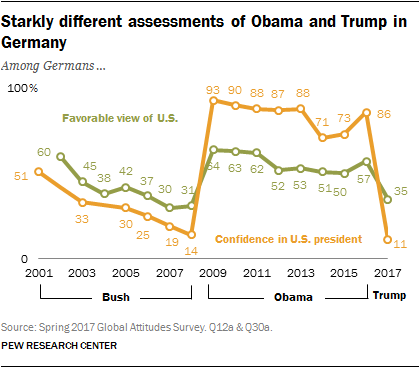Give some essential details in this illustration. The color of a graph whose lowest value is 11 is orange. The number of values on the green graph that exceed 60 is 8. 